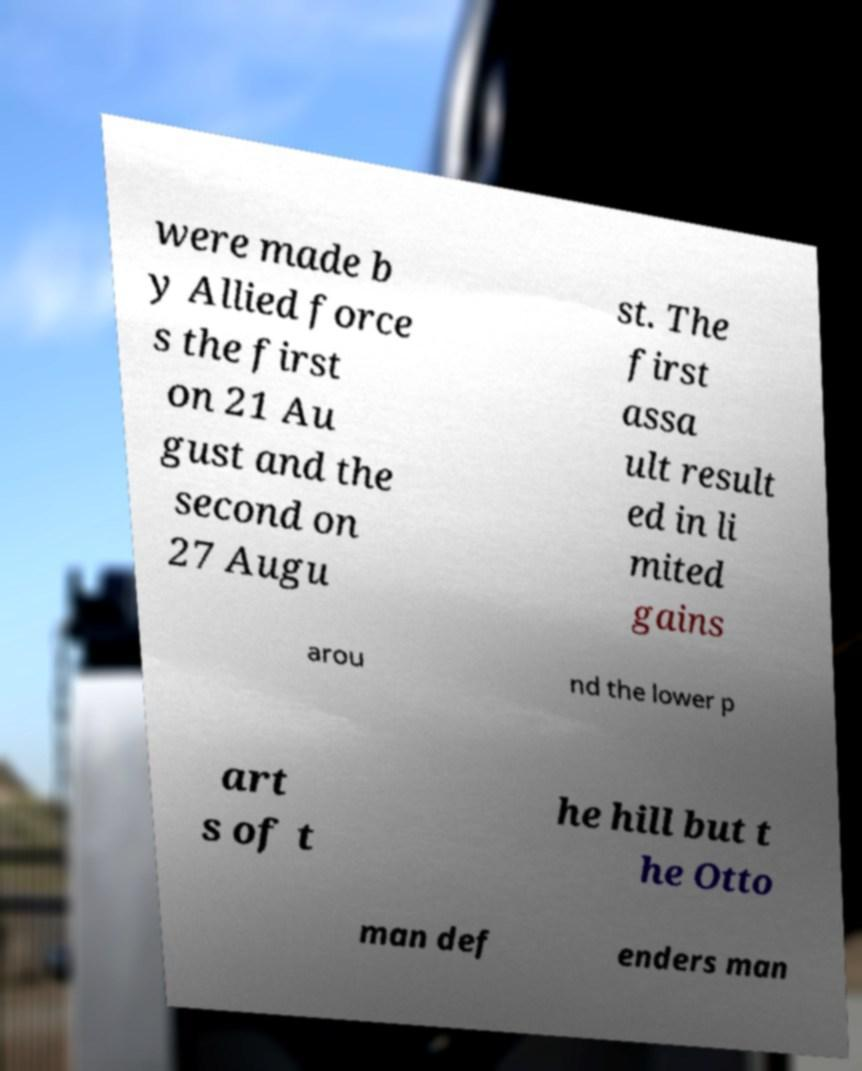Can you accurately transcribe the text from the provided image for me? were made b y Allied force s the first on 21 Au gust and the second on 27 Augu st. The first assa ult result ed in li mited gains arou nd the lower p art s of t he hill but t he Otto man def enders man 